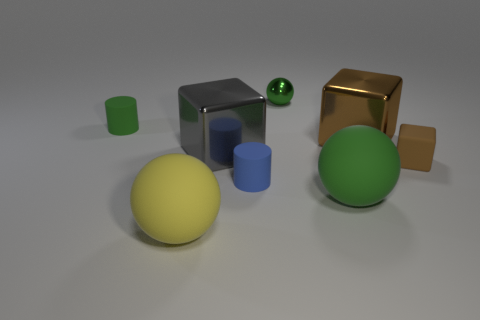There is a green thing that is behind the tiny blue object and on the right side of the green matte cylinder; what material is it?
Your answer should be compact. Metal. What color is the small metal ball?
Make the answer very short. Green. What number of large gray shiny objects are the same shape as the large brown metal object?
Your response must be concise. 1. Is the material of the tiny brown object to the right of the small metallic thing the same as the small cylinder on the left side of the blue matte object?
Make the answer very short. Yes. There is a green ball that is behind the large gray cube that is behind the tiny blue cylinder; what is its size?
Offer a very short reply. Small. Are there any other things that have the same size as the green cylinder?
Ensure brevity in your answer.  Yes. There is a yellow object that is the same shape as the small green metallic thing; what is it made of?
Provide a short and direct response. Rubber. Do the large metal object that is to the right of the tiny green ball and the brown thing that is on the right side of the big brown object have the same shape?
Offer a very short reply. Yes. Are there more cylinders than gray metal things?
Your answer should be compact. Yes. How big is the rubber block?
Ensure brevity in your answer.  Small. 